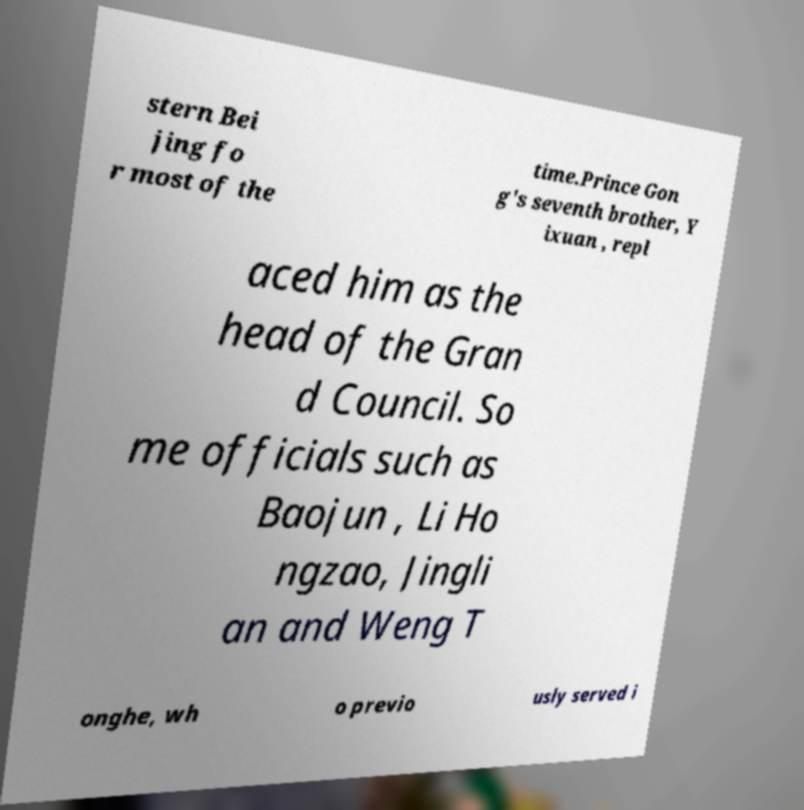For documentation purposes, I need the text within this image transcribed. Could you provide that? stern Bei jing fo r most of the time.Prince Gon g's seventh brother, Y ixuan , repl aced him as the head of the Gran d Council. So me officials such as Baojun , Li Ho ngzao, Jingli an and Weng T onghe, wh o previo usly served i 